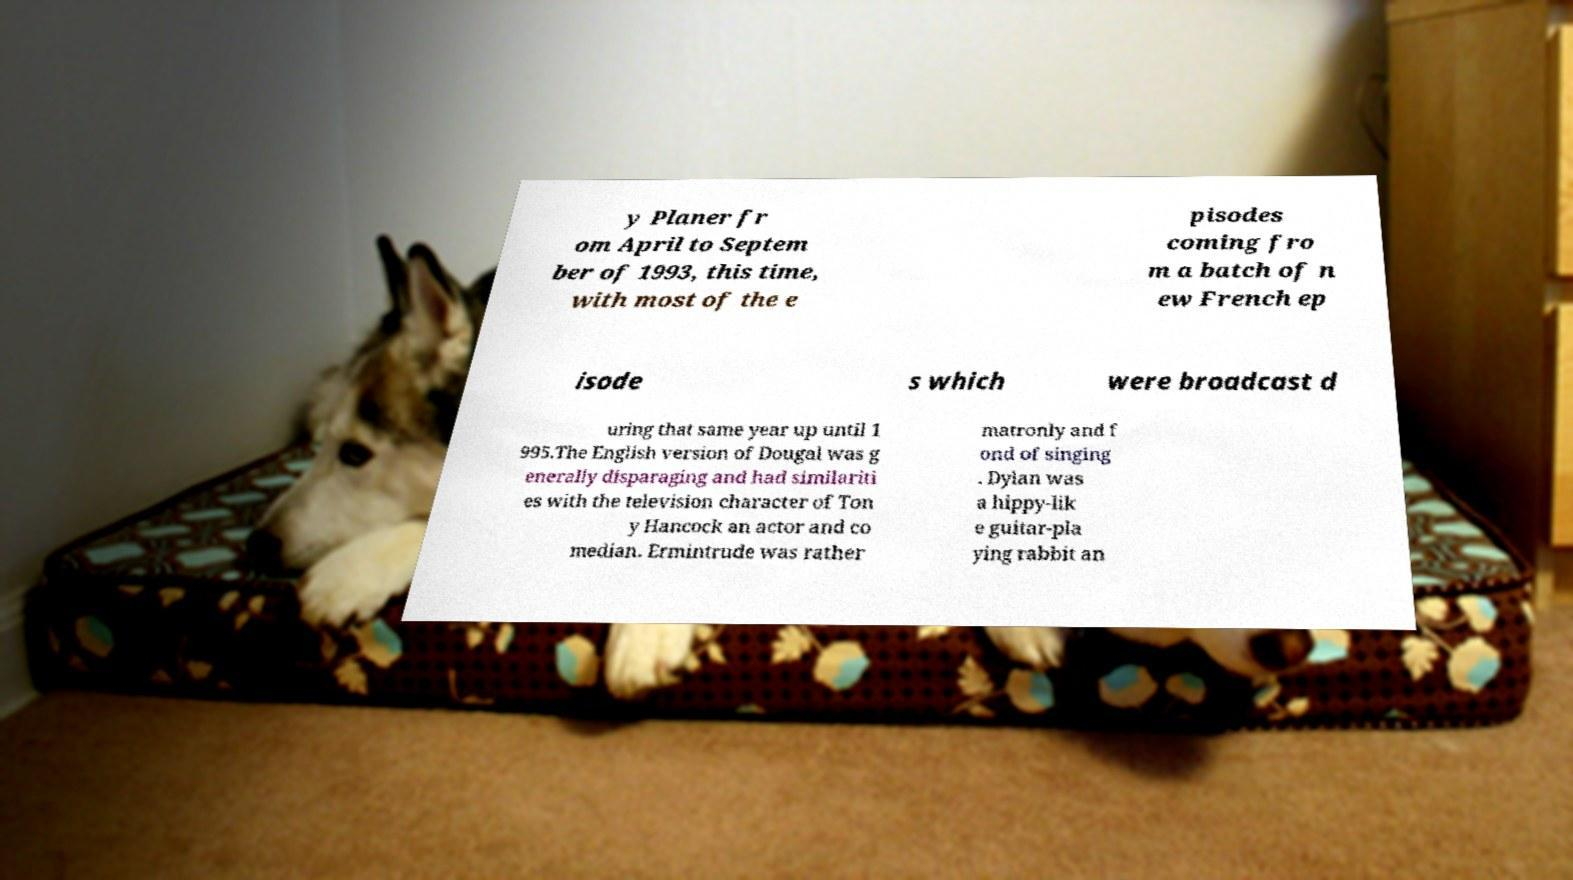I need the written content from this picture converted into text. Can you do that? y Planer fr om April to Septem ber of 1993, this time, with most of the e pisodes coming fro m a batch of n ew French ep isode s which were broadcast d uring that same year up until 1 995.The English version of Dougal was g enerally disparaging and had similariti es with the television character of Ton y Hancock an actor and co median. Ermintrude was rather matronly and f ond of singing . Dylan was a hippy-lik e guitar-pla ying rabbit an 